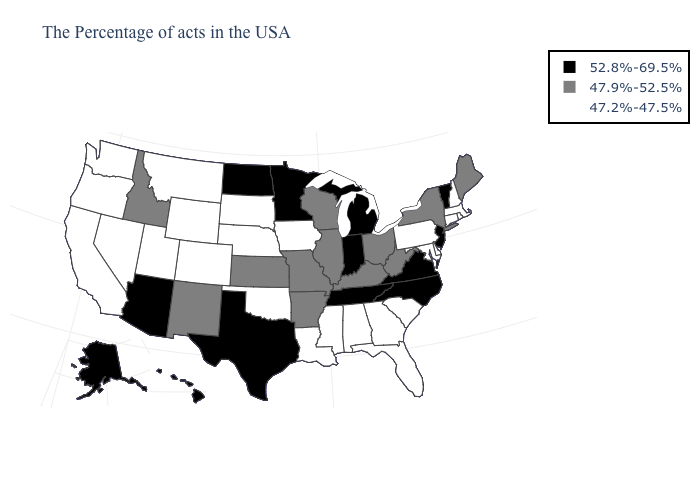What is the value of Ohio?
Answer briefly. 47.9%-52.5%. What is the value of Oklahoma?
Write a very short answer. 47.2%-47.5%. Name the states that have a value in the range 47.9%-52.5%?
Concise answer only. Maine, New York, West Virginia, Ohio, Kentucky, Wisconsin, Illinois, Missouri, Arkansas, Kansas, New Mexico, Idaho. Among the states that border Indiana , which have the lowest value?
Short answer required. Ohio, Kentucky, Illinois. What is the value of Pennsylvania?
Keep it brief. 47.2%-47.5%. What is the highest value in the USA?
Answer briefly. 52.8%-69.5%. What is the value of South Carolina?
Give a very brief answer. 47.2%-47.5%. Does Montana have the highest value in the USA?
Quick response, please. No. What is the highest value in the USA?
Keep it brief. 52.8%-69.5%. What is the highest value in the USA?
Answer briefly. 52.8%-69.5%. Name the states that have a value in the range 47.9%-52.5%?
Be succinct. Maine, New York, West Virginia, Ohio, Kentucky, Wisconsin, Illinois, Missouri, Arkansas, Kansas, New Mexico, Idaho. What is the value of Texas?
Concise answer only. 52.8%-69.5%. Does New Hampshire have a higher value than South Carolina?
Concise answer only. No. What is the lowest value in states that border Washington?
Concise answer only. 47.2%-47.5%. Among the states that border Oklahoma , which have the highest value?
Concise answer only. Texas. 